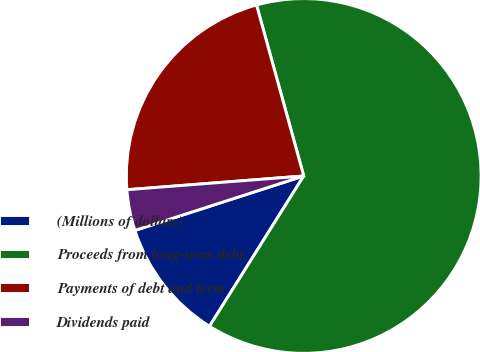Convert chart to OTSL. <chart><loc_0><loc_0><loc_500><loc_500><pie_chart><fcel>(Millions of dollars)<fcel>Proceeds from long-term debt<fcel>Payments of debt and term<fcel>Dividends paid<nl><fcel>11.12%<fcel>63.2%<fcel>21.95%<fcel>3.73%<nl></chart> 